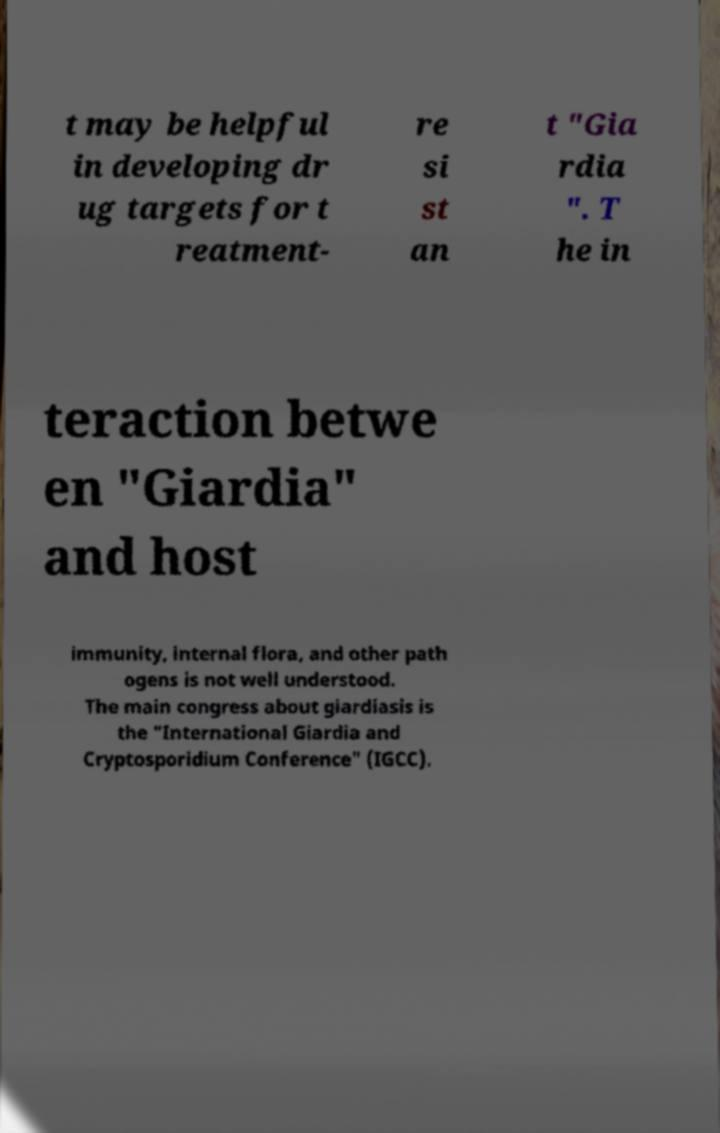For documentation purposes, I need the text within this image transcribed. Could you provide that? t may be helpful in developing dr ug targets for t reatment- re si st an t "Gia rdia ". T he in teraction betwe en "Giardia" and host immunity, internal flora, and other path ogens is not well understood. The main congress about giardiasis is the "International Giardia and Cryptosporidium Conference" (IGCC). 